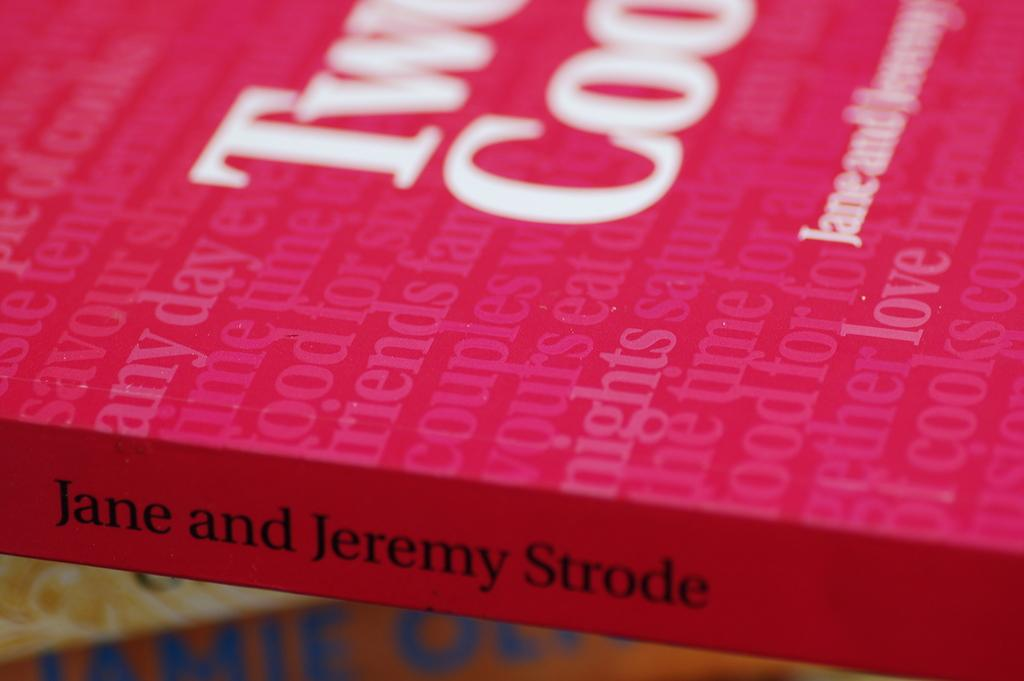What color is the book that is visible in the image? There is a pink book in the image. What can be found on the book? There is text visible on the book. What industry is depicted in the image? There is no industry present in the image; it only features a pink book with text on it. How does the sky look like in the image? There is no sky visible in the image; it only features a pink book with text on it. 